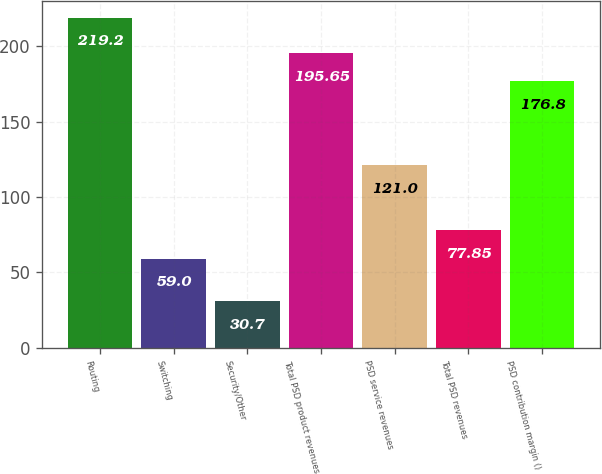<chart> <loc_0><loc_0><loc_500><loc_500><bar_chart><fcel>Routing<fcel>Switching<fcel>Security/Other<fcel>Total PSD product revenues<fcel>PSD service revenues<fcel>Total PSD revenues<fcel>PSD contribution margin ()<nl><fcel>219.2<fcel>59<fcel>30.7<fcel>195.65<fcel>121<fcel>77.85<fcel>176.8<nl></chart> 